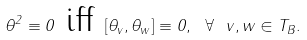<formula> <loc_0><loc_0><loc_500><loc_500>\theta ^ { 2 } \equiv 0 \ \text {iff} \ [ \theta _ { v } , \theta _ { w } ] \equiv 0 , \ \forall \ v , w \in T _ { B } .</formula> 